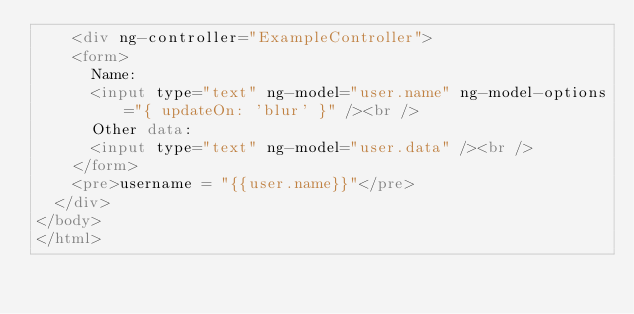<code> <loc_0><loc_0><loc_500><loc_500><_HTML_>    <div ng-controller="ExampleController">
    <form>
      Name:
      <input type="text" ng-model="user.name" ng-model-options="{ updateOn: 'blur' }" /><br />
      Other data:
      <input type="text" ng-model="user.data" /><br />
    </form>
    <pre>username = "{{user.name}}"</pre>
  </div>
</body>
</html></code> 